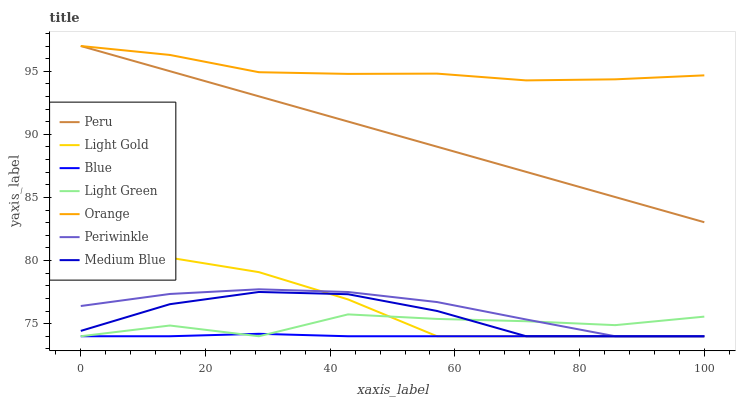Does Blue have the minimum area under the curve?
Answer yes or no. Yes. Does Orange have the maximum area under the curve?
Answer yes or no. Yes. Does Peru have the minimum area under the curve?
Answer yes or no. No. Does Peru have the maximum area under the curve?
Answer yes or no. No. Is Peru the smoothest?
Answer yes or no. Yes. Is Light Green the roughest?
Answer yes or no. Yes. Is Medium Blue the smoothest?
Answer yes or no. No. Is Medium Blue the roughest?
Answer yes or no. No. Does Blue have the lowest value?
Answer yes or no. Yes. Does Peru have the lowest value?
Answer yes or no. No. Does Orange have the highest value?
Answer yes or no. Yes. Does Medium Blue have the highest value?
Answer yes or no. No. Is Blue less than Peru?
Answer yes or no. Yes. Is Orange greater than Blue?
Answer yes or no. Yes. Does Light Green intersect Blue?
Answer yes or no. Yes. Is Light Green less than Blue?
Answer yes or no. No. Is Light Green greater than Blue?
Answer yes or no. No. Does Blue intersect Peru?
Answer yes or no. No. 